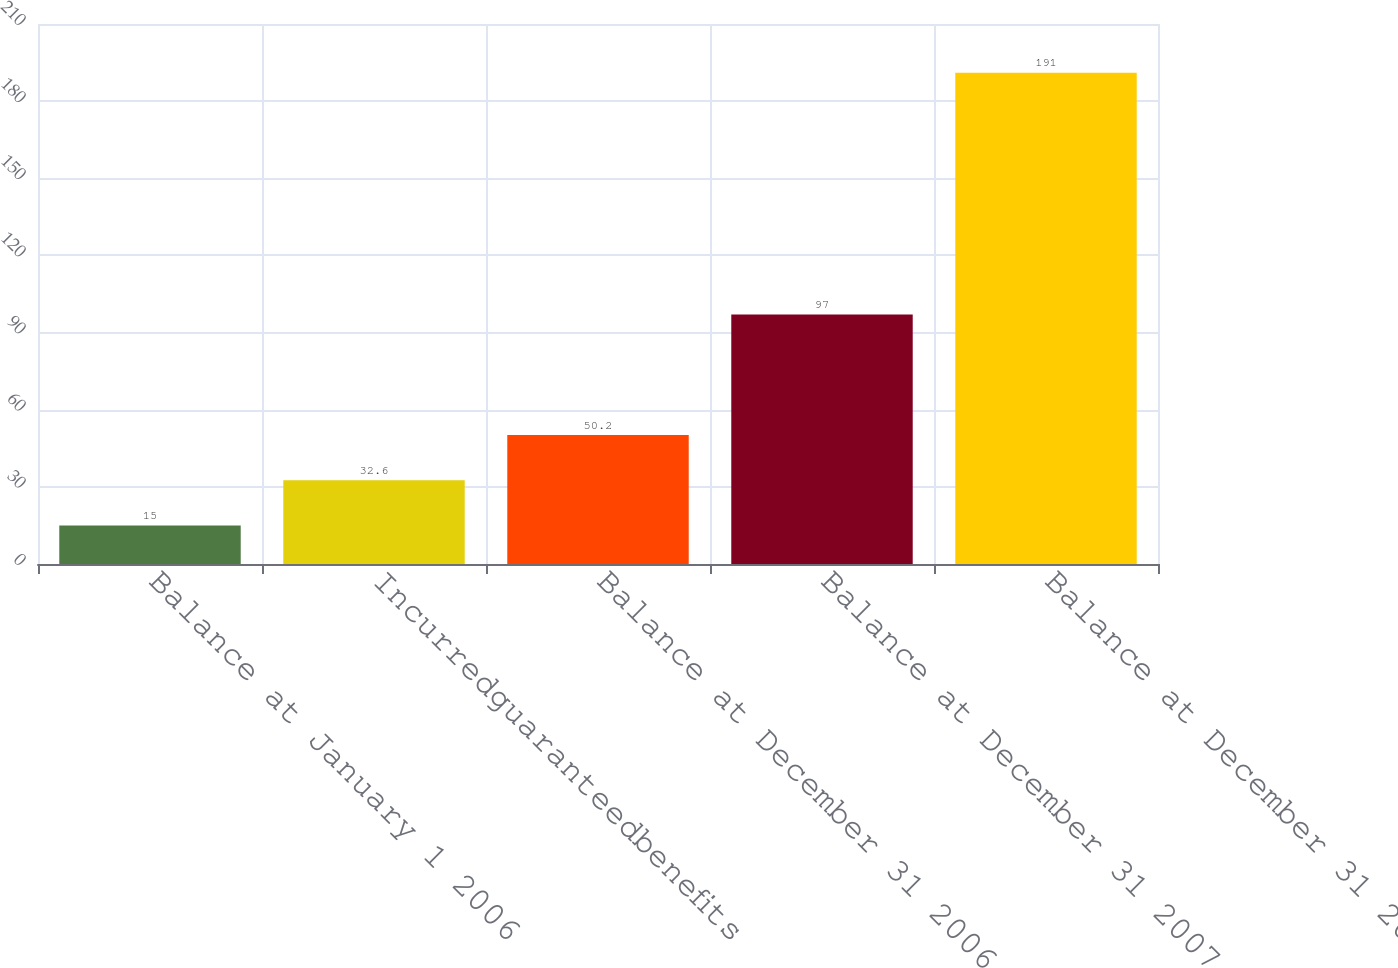Convert chart. <chart><loc_0><loc_0><loc_500><loc_500><bar_chart><fcel>Balance at January 1 2006<fcel>Incurredguaranteedbenefits<fcel>Balance at December 31 2006<fcel>Balance at December 31 2007<fcel>Balance at December 31 2008<nl><fcel>15<fcel>32.6<fcel>50.2<fcel>97<fcel>191<nl></chart> 